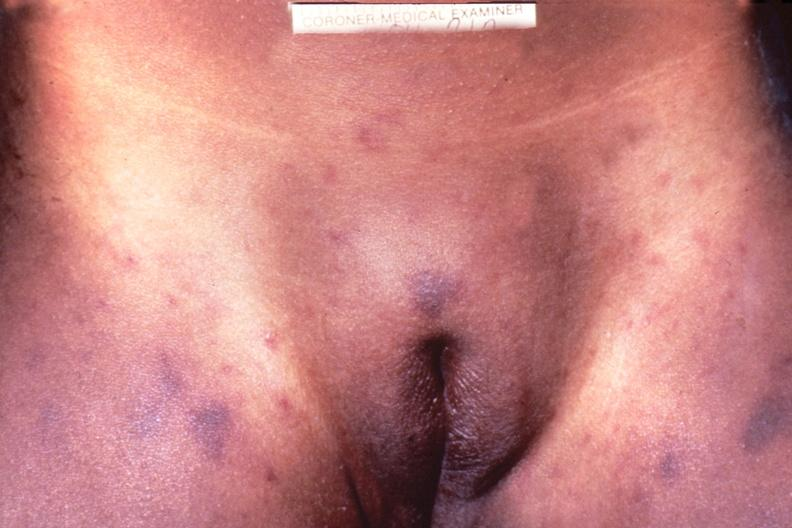where is this?
Answer the question using a single word or phrase. Skin 